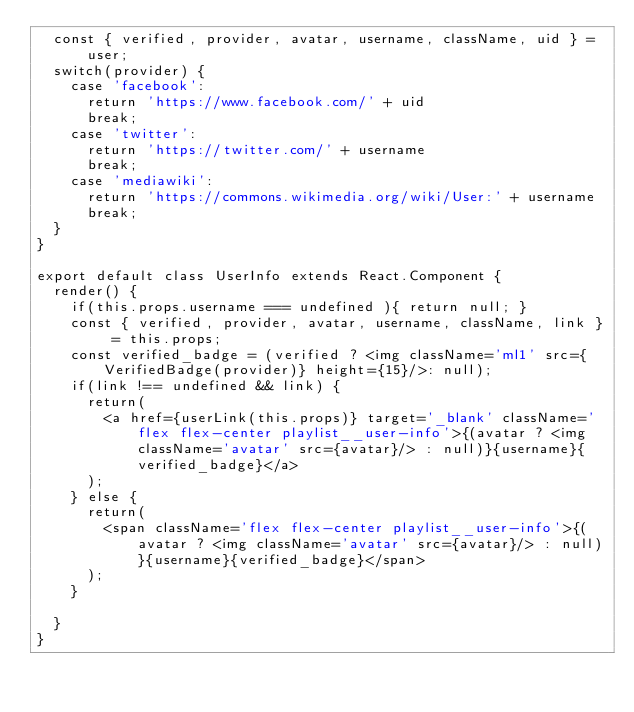<code> <loc_0><loc_0><loc_500><loc_500><_JavaScript_>  const { verified, provider, avatar, username, className, uid } = user;
  switch(provider) {
    case 'facebook':
      return 'https://www.facebook.com/' + uid
      break;
    case 'twitter':
      return 'https://twitter.com/' + username
      break;
    case 'mediawiki':
      return 'https://commons.wikimedia.org/wiki/User:' + username
      break;
  }
}

export default class UserInfo extends React.Component {
  render() {
    if(this.props.username === undefined ){ return null; }
    const { verified, provider, avatar, username, className, link } = this.props;
    const verified_badge = (verified ? <img className='ml1' src={VerifiedBadge(provider)} height={15}/>: null);
    if(link !== undefined && link) {
      return( 
        <a href={userLink(this.props)} target='_blank' className='flex flex-center playlist__user-info'>{(avatar ? <img className='avatar' src={avatar}/> : null)}{username}{verified_badge}</a>
      );
    } else {
      return( 
        <span className='flex flex-center playlist__user-info'>{(avatar ? <img className='avatar' src={avatar}/> : null)}{username}{verified_badge}</span>
      );
    }
    
  }
}</code> 